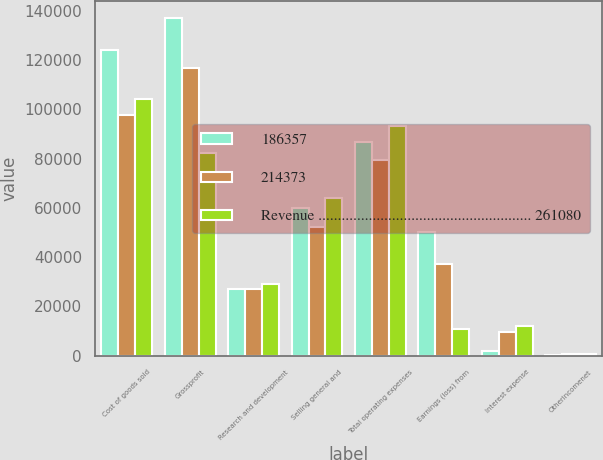<chart> <loc_0><loc_0><loc_500><loc_500><stacked_bar_chart><ecel><fcel>Cost of goods sold<fcel>Grossprofit<fcel>Research and development<fcel>Selling general and<fcel>Total operating expenses<fcel>Earnings (loss) from<fcel>Interest expense<fcel>Otherincomenet<nl><fcel>186357<fcel>124060<fcel>137020<fcel>26892<fcel>59951<fcel>86843<fcel>50177<fcel>1679<fcel>395<nl><fcel>214373<fcel>97541<fcel>116832<fcel>27235<fcel>52285<fcel>79520<fcel>37312<fcel>9423<fcel>854<nl><fcel>Revenue ....................................................... 261080<fcel>104116<fcel>82241<fcel>29150<fcel>63916<fcel>93066<fcel>10825<fcel>12022<fcel>518<nl></chart> 